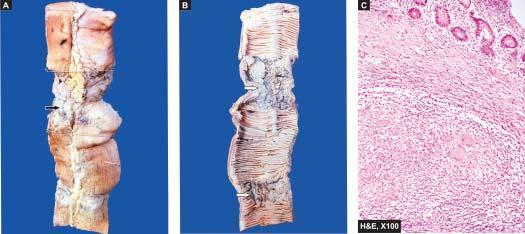s the wall of intestine in the area of narrowed lumen thickened?
Answer the question using a single word or phrase. Yes 